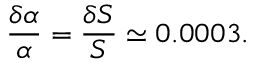Convert formula to latex. <formula><loc_0><loc_0><loc_500><loc_500>\frac { \delta \alpha } { \alpha } = \frac { \delta S } { S } \simeq 0 . 0 0 0 3 .</formula> 